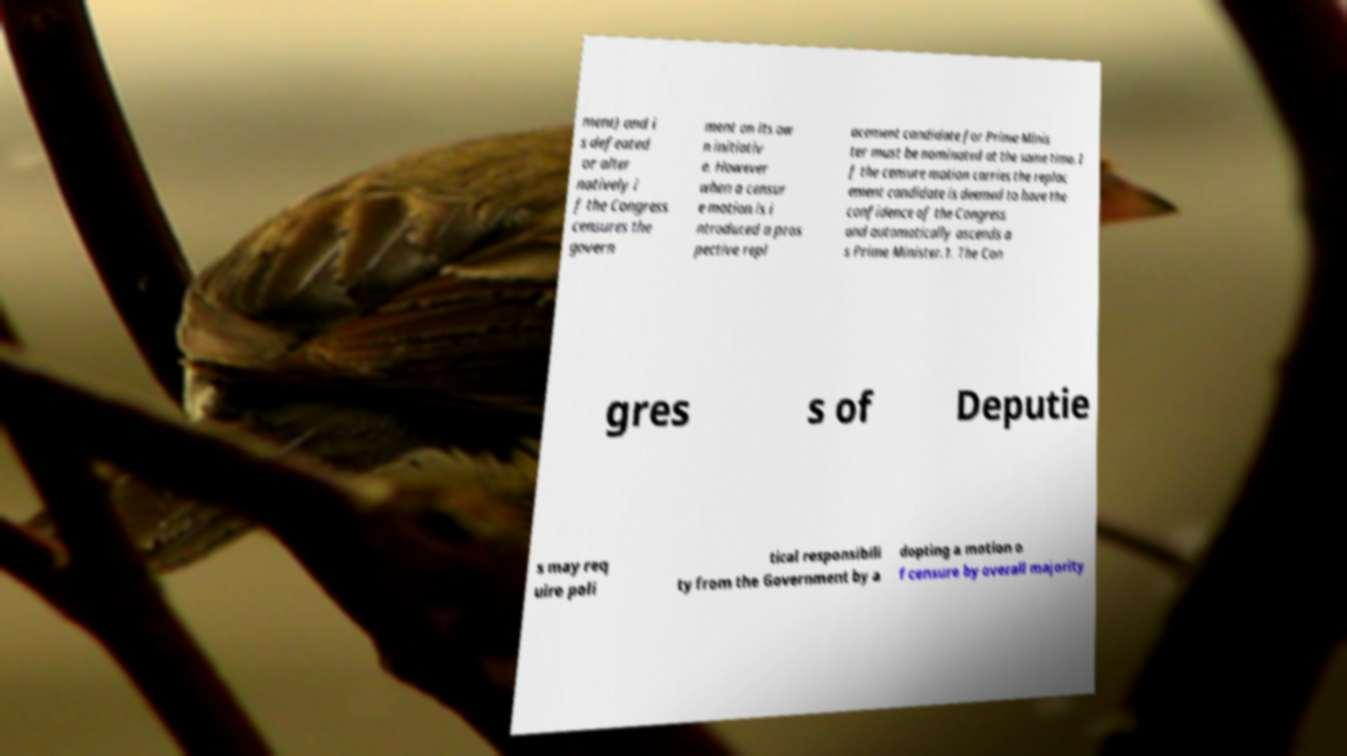Could you assist in decoding the text presented in this image and type it out clearly? ment) and i s defeated or alter natively i f the Congress censures the govern ment on its ow n initiativ e. However when a censur e motion is i ntroduced a pros pective repl acement candidate for Prime Minis ter must be nominated at the same time. I f the censure motion carries the replac ement candidate is deemed to have the confidence of the Congress and automatically ascends a s Prime Minister.1. The Con gres s of Deputie s may req uire poli tical responsibili ty from the Government by a dopting a motion o f censure by overall majority 